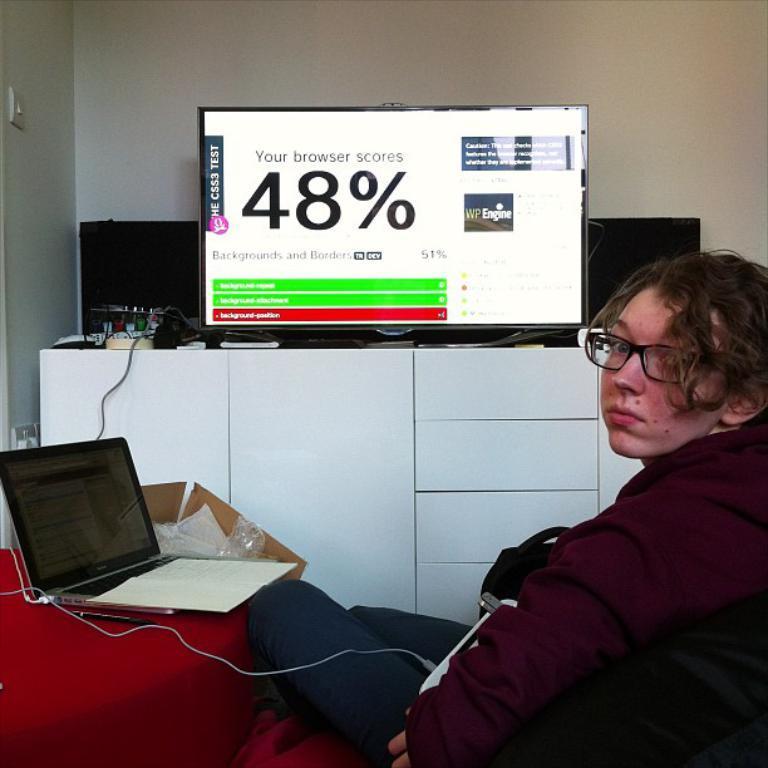Describe this image in one or two sentences. In this image we can see a person. There is a television in the image. There is a laptop and few other objects in the image. We can see the wall in the image. There is a power socket on the wall. 